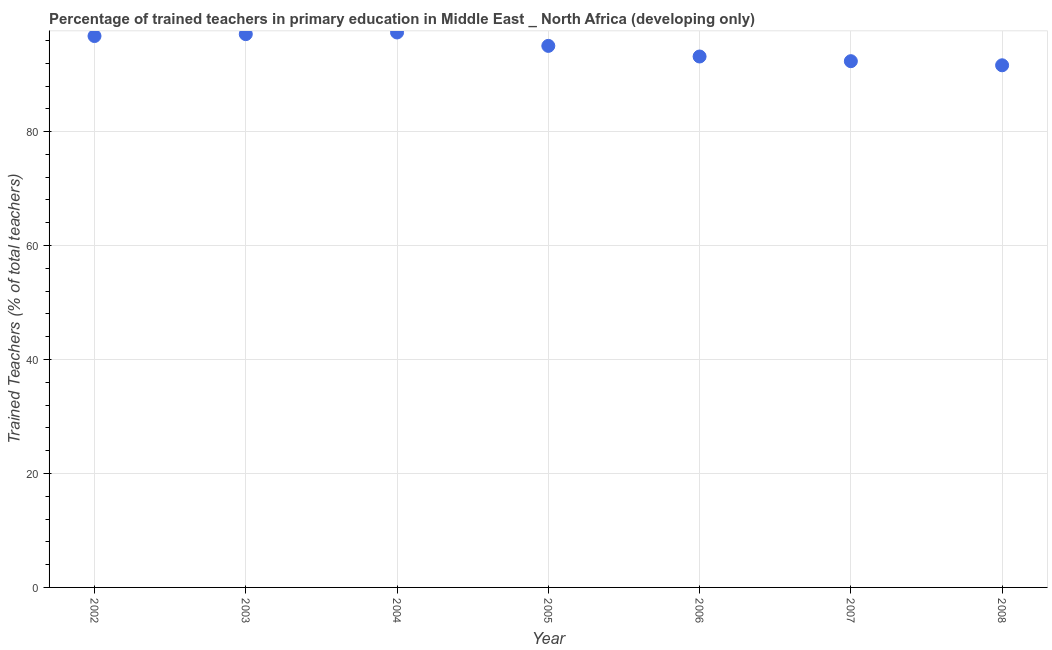What is the percentage of trained teachers in 2006?
Provide a short and direct response. 93.18. Across all years, what is the maximum percentage of trained teachers?
Provide a short and direct response. 97.4. Across all years, what is the minimum percentage of trained teachers?
Make the answer very short. 91.64. What is the sum of the percentage of trained teachers?
Your answer should be very brief. 663.48. What is the difference between the percentage of trained teachers in 2006 and 2008?
Provide a short and direct response. 1.54. What is the average percentage of trained teachers per year?
Give a very brief answer. 94.78. What is the median percentage of trained teachers?
Your answer should be compact. 95.04. Do a majority of the years between 2007 and 2002 (inclusive) have percentage of trained teachers greater than 80 %?
Your answer should be compact. Yes. What is the ratio of the percentage of trained teachers in 2002 to that in 2008?
Offer a very short reply. 1.06. Is the difference between the percentage of trained teachers in 2002 and 2008 greater than the difference between any two years?
Make the answer very short. No. What is the difference between the highest and the second highest percentage of trained teachers?
Your answer should be compact. 0.3. Is the sum of the percentage of trained teachers in 2006 and 2007 greater than the maximum percentage of trained teachers across all years?
Offer a terse response. Yes. What is the difference between the highest and the lowest percentage of trained teachers?
Provide a succinct answer. 5.76. In how many years, is the percentage of trained teachers greater than the average percentage of trained teachers taken over all years?
Provide a short and direct response. 4. How many dotlines are there?
Your answer should be very brief. 1. How many years are there in the graph?
Keep it short and to the point. 7. Does the graph contain any zero values?
Ensure brevity in your answer.  No. What is the title of the graph?
Ensure brevity in your answer.  Percentage of trained teachers in primary education in Middle East _ North Africa (developing only). What is the label or title of the X-axis?
Offer a terse response. Year. What is the label or title of the Y-axis?
Your response must be concise. Trained Teachers (% of total teachers). What is the Trained Teachers (% of total teachers) in 2002?
Your response must be concise. 96.77. What is the Trained Teachers (% of total teachers) in 2003?
Ensure brevity in your answer.  97.1. What is the Trained Teachers (% of total teachers) in 2004?
Provide a succinct answer. 97.4. What is the Trained Teachers (% of total teachers) in 2005?
Offer a terse response. 95.04. What is the Trained Teachers (% of total teachers) in 2006?
Offer a very short reply. 93.18. What is the Trained Teachers (% of total teachers) in 2007?
Ensure brevity in your answer.  92.36. What is the Trained Teachers (% of total teachers) in 2008?
Offer a terse response. 91.64. What is the difference between the Trained Teachers (% of total teachers) in 2002 and 2003?
Make the answer very short. -0.33. What is the difference between the Trained Teachers (% of total teachers) in 2002 and 2004?
Make the answer very short. -0.63. What is the difference between the Trained Teachers (% of total teachers) in 2002 and 2005?
Your answer should be compact. 1.73. What is the difference between the Trained Teachers (% of total teachers) in 2002 and 2006?
Your answer should be compact. 3.59. What is the difference between the Trained Teachers (% of total teachers) in 2002 and 2007?
Keep it short and to the point. 4.41. What is the difference between the Trained Teachers (% of total teachers) in 2002 and 2008?
Your response must be concise. 5.13. What is the difference between the Trained Teachers (% of total teachers) in 2003 and 2004?
Ensure brevity in your answer.  -0.3. What is the difference between the Trained Teachers (% of total teachers) in 2003 and 2005?
Provide a short and direct response. 2.06. What is the difference between the Trained Teachers (% of total teachers) in 2003 and 2006?
Give a very brief answer. 3.92. What is the difference between the Trained Teachers (% of total teachers) in 2003 and 2007?
Your response must be concise. 4.74. What is the difference between the Trained Teachers (% of total teachers) in 2003 and 2008?
Provide a short and direct response. 5.46. What is the difference between the Trained Teachers (% of total teachers) in 2004 and 2005?
Make the answer very short. 2.35. What is the difference between the Trained Teachers (% of total teachers) in 2004 and 2006?
Your answer should be very brief. 4.22. What is the difference between the Trained Teachers (% of total teachers) in 2004 and 2007?
Offer a terse response. 5.04. What is the difference between the Trained Teachers (% of total teachers) in 2004 and 2008?
Give a very brief answer. 5.76. What is the difference between the Trained Teachers (% of total teachers) in 2005 and 2006?
Ensure brevity in your answer.  1.86. What is the difference between the Trained Teachers (% of total teachers) in 2005 and 2007?
Your answer should be compact. 2.69. What is the difference between the Trained Teachers (% of total teachers) in 2005 and 2008?
Make the answer very short. 3.41. What is the difference between the Trained Teachers (% of total teachers) in 2006 and 2007?
Give a very brief answer. 0.82. What is the difference between the Trained Teachers (% of total teachers) in 2006 and 2008?
Your answer should be compact. 1.54. What is the difference between the Trained Teachers (% of total teachers) in 2007 and 2008?
Keep it short and to the point. 0.72. What is the ratio of the Trained Teachers (% of total teachers) in 2002 to that in 2003?
Provide a succinct answer. 1. What is the ratio of the Trained Teachers (% of total teachers) in 2002 to that in 2004?
Offer a terse response. 0.99. What is the ratio of the Trained Teachers (% of total teachers) in 2002 to that in 2005?
Give a very brief answer. 1.02. What is the ratio of the Trained Teachers (% of total teachers) in 2002 to that in 2006?
Offer a very short reply. 1.04. What is the ratio of the Trained Teachers (% of total teachers) in 2002 to that in 2007?
Keep it short and to the point. 1.05. What is the ratio of the Trained Teachers (% of total teachers) in 2002 to that in 2008?
Ensure brevity in your answer.  1.06. What is the ratio of the Trained Teachers (% of total teachers) in 2003 to that in 2005?
Provide a succinct answer. 1.02. What is the ratio of the Trained Teachers (% of total teachers) in 2003 to that in 2006?
Provide a short and direct response. 1.04. What is the ratio of the Trained Teachers (% of total teachers) in 2003 to that in 2007?
Provide a succinct answer. 1.05. What is the ratio of the Trained Teachers (% of total teachers) in 2003 to that in 2008?
Your answer should be compact. 1.06. What is the ratio of the Trained Teachers (% of total teachers) in 2004 to that in 2006?
Give a very brief answer. 1.04. What is the ratio of the Trained Teachers (% of total teachers) in 2004 to that in 2007?
Provide a succinct answer. 1.05. What is the ratio of the Trained Teachers (% of total teachers) in 2004 to that in 2008?
Your answer should be compact. 1.06. What is the ratio of the Trained Teachers (% of total teachers) in 2005 to that in 2008?
Offer a very short reply. 1.04. What is the ratio of the Trained Teachers (% of total teachers) in 2006 to that in 2007?
Ensure brevity in your answer.  1.01. What is the ratio of the Trained Teachers (% of total teachers) in 2007 to that in 2008?
Your response must be concise. 1.01. 